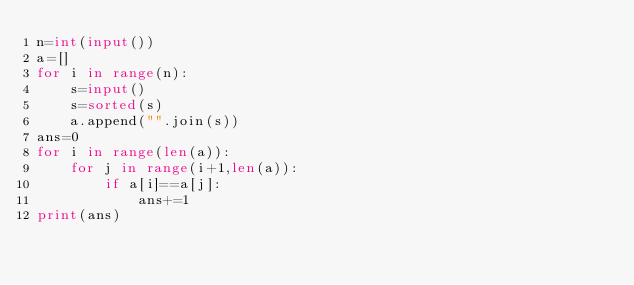<code> <loc_0><loc_0><loc_500><loc_500><_Python_>n=int(input())
a=[]
for i in range(n):
    s=input()
    s=sorted(s)
    a.append("".join(s))
ans=0
for i in range(len(a)):
    for j in range(i+1,len(a)):
        if a[i]==a[j]:
            ans+=1
print(ans)</code> 